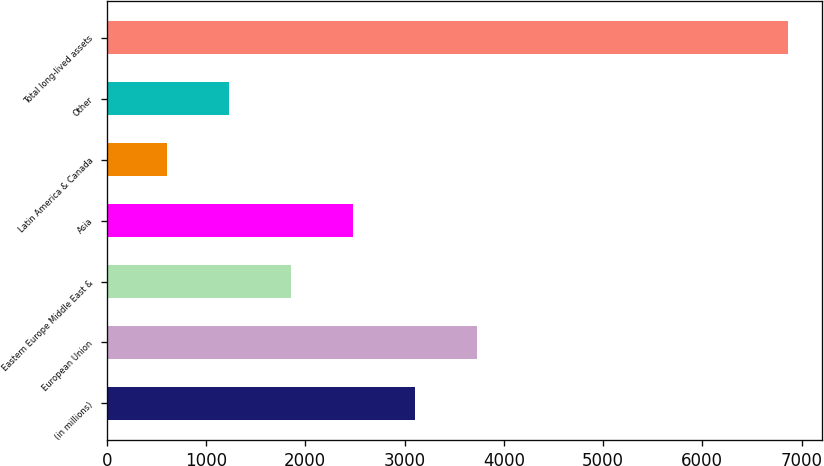<chart> <loc_0><loc_0><loc_500><loc_500><bar_chart><fcel>(in millions)<fcel>European Union<fcel>Eastern Europe Middle East &<fcel>Asia<fcel>Latin America & Canada<fcel>Other<fcel>Total long-lived assets<nl><fcel>3108.6<fcel>3734.5<fcel>1856.8<fcel>2482.7<fcel>605<fcel>1230.9<fcel>6864<nl></chart> 